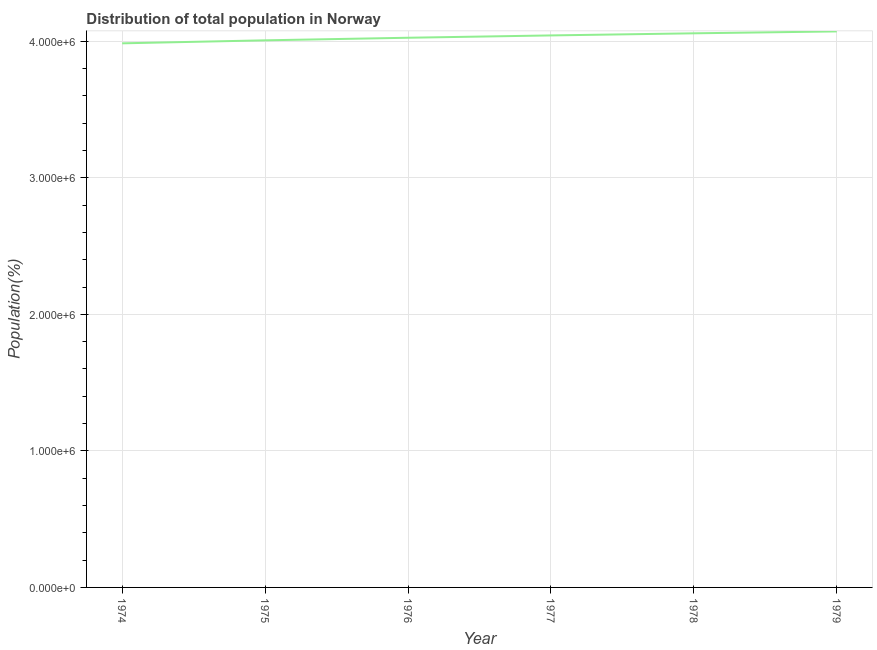What is the population in 1977?
Provide a short and direct response. 4.04e+06. Across all years, what is the maximum population?
Offer a terse response. 4.07e+06. Across all years, what is the minimum population?
Offer a terse response. 3.99e+06. In which year was the population maximum?
Your answer should be very brief. 1979. In which year was the population minimum?
Keep it short and to the point. 1974. What is the sum of the population?
Provide a short and direct response. 2.42e+07. What is the difference between the population in 1974 and 1977?
Offer a terse response. -5.79e+04. What is the average population per year?
Offer a very short reply. 4.03e+06. What is the median population?
Your answer should be very brief. 4.03e+06. In how many years, is the population greater than 2200000 %?
Provide a short and direct response. 6. Do a majority of the years between 1974 and 1975 (inclusive) have population greater than 3600000 %?
Offer a terse response. Yes. What is the ratio of the population in 1976 to that in 1979?
Offer a terse response. 0.99. Is the population in 1976 less than that in 1978?
Your answer should be very brief. Yes. What is the difference between the highest and the second highest population?
Provide a succinct answer. 1.38e+04. What is the difference between the highest and the lowest population?
Ensure brevity in your answer.  8.73e+04. Does the population monotonically increase over the years?
Provide a succinct answer. Yes. How many lines are there?
Your answer should be very brief. 1. What is the difference between two consecutive major ticks on the Y-axis?
Make the answer very short. 1.00e+06. Are the values on the major ticks of Y-axis written in scientific E-notation?
Offer a very short reply. Yes. Does the graph contain any zero values?
Provide a short and direct response. No. Does the graph contain grids?
Offer a terse response. Yes. What is the title of the graph?
Your response must be concise. Distribution of total population in Norway . What is the label or title of the X-axis?
Give a very brief answer. Year. What is the label or title of the Y-axis?
Provide a succinct answer. Population(%). What is the Population(%) of 1974?
Your answer should be very brief. 3.99e+06. What is the Population(%) of 1975?
Offer a terse response. 4.01e+06. What is the Population(%) in 1976?
Make the answer very short. 4.03e+06. What is the Population(%) of 1977?
Ensure brevity in your answer.  4.04e+06. What is the Population(%) of 1978?
Provide a short and direct response. 4.06e+06. What is the Population(%) of 1979?
Provide a short and direct response. 4.07e+06. What is the difference between the Population(%) in 1974 and 1975?
Give a very brief answer. -2.21e+04. What is the difference between the Population(%) in 1974 and 1976?
Provide a short and direct response. -4.09e+04. What is the difference between the Population(%) in 1974 and 1977?
Your answer should be compact. -5.79e+04. What is the difference between the Population(%) in 1974 and 1978?
Provide a succinct answer. -7.34e+04. What is the difference between the Population(%) in 1974 and 1979?
Your response must be concise. -8.73e+04. What is the difference between the Population(%) in 1975 and 1976?
Offer a terse response. -1.88e+04. What is the difference between the Population(%) in 1975 and 1977?
Keep it short and to the point. -3.59e+04. What is the difference between the Population(%) in 1975 and 1978?
Ensure brevity in your answer.  -5.14e+04. What is the difference between the Population(%) in 1975 and 1979?
Your answer should be compact. -6.52e+04. What is the difference between the Population(%) in 1976 and 1977?
Offer a terse response. -1.71e+04. What is the difference between the Population(%) in 1976 and 1978?
Ensure brevity in your answer.  -3.25e+04. What is the difference between the Population(%) in 1976 and 1979?
Offer a terse response. -4.64e+04. What is the difference between the Population(%) in 1977 and 1978?
Provide a succinct answer. -1.55e+04. What is the difference between the Population(%) in 1977 and 1979?
Offer a terse response. -2.93e+04. What is the difference between the Population(%) in 1978 and 1979?
Offer a terse response. -1.38e+04. What is the ratio of the Population(%) in 1974 to that in 1975?
Provide a succinct answer. 0.99. What is the ratio of the Population(%) in 1974 to that in 1978?
Provide a short and direct response. 0.98. What is the ratio of the Population(%) in 1974 to that in 1979?
Your answer should be very brief. 0.98. What is the ratio of the Population(%) in 1975 to that in 1976?
Keep it short and to the point. 0.99. What is the ratio of the Population(%) in 1975 to that in 1977?
Your answer should be very brief. 0.99. What is the ratio of the Population(%) in 1975 to that in 1979?
Provide a succinct answer. 0.98. What is the ratio of the Population(%) in 1976 to that in 1977?
Offer a very short reply. 1. What is the ratio of the Population(%) in 1977 to that in 1978?
Offer a very short reply. 1. What is the ratio of the Population(%) in 1978 to that in 1979?
Ensure brevity in your answer.  1. 